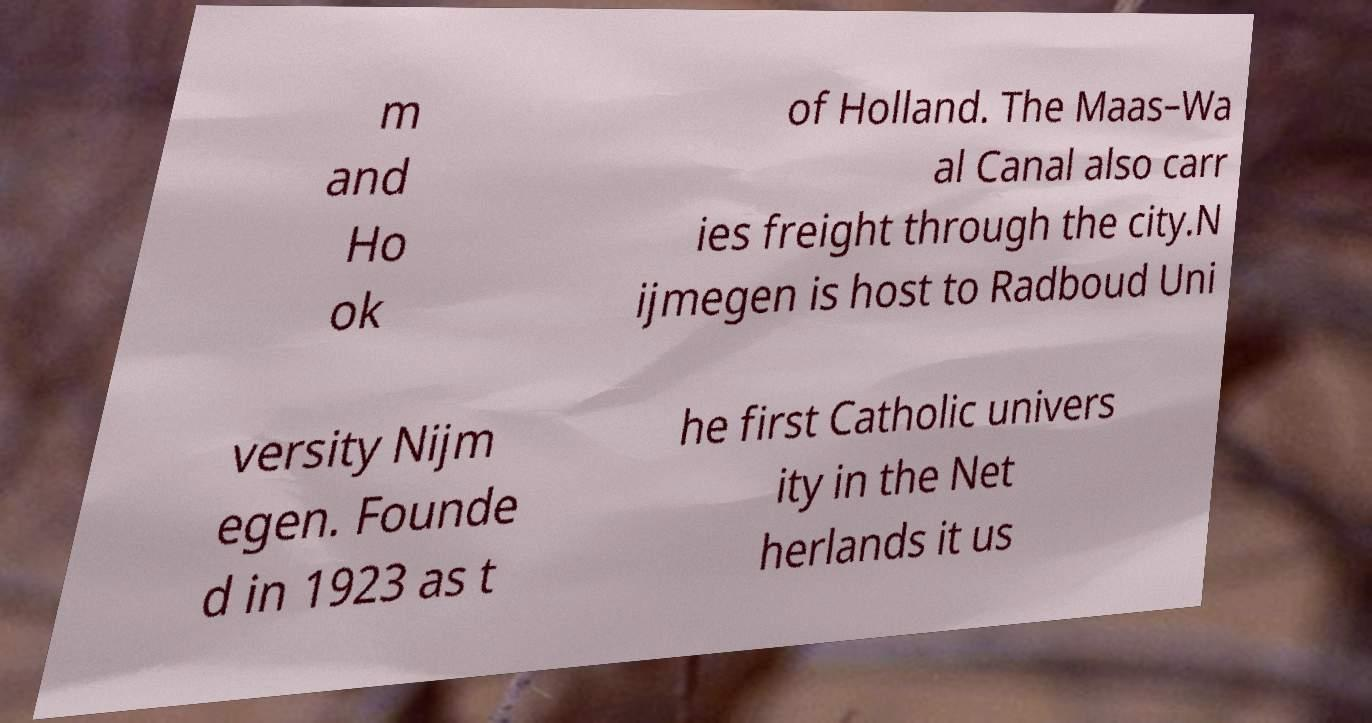Could you assist in decoding the text presented in this image and type it out clearly? m and Ho ok of Holland. The Maas–Wa al Canal also carr ies freight through the city.N ijmegen is host to Radboud Uni versity Nijm egen. Founde d in 1923 as t he first Catholic univers ity in the Net herlands it us 